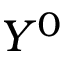<formula> <loc_0><loc_0><loc_500><loc_500>Y ^ { 0 }</formula> 